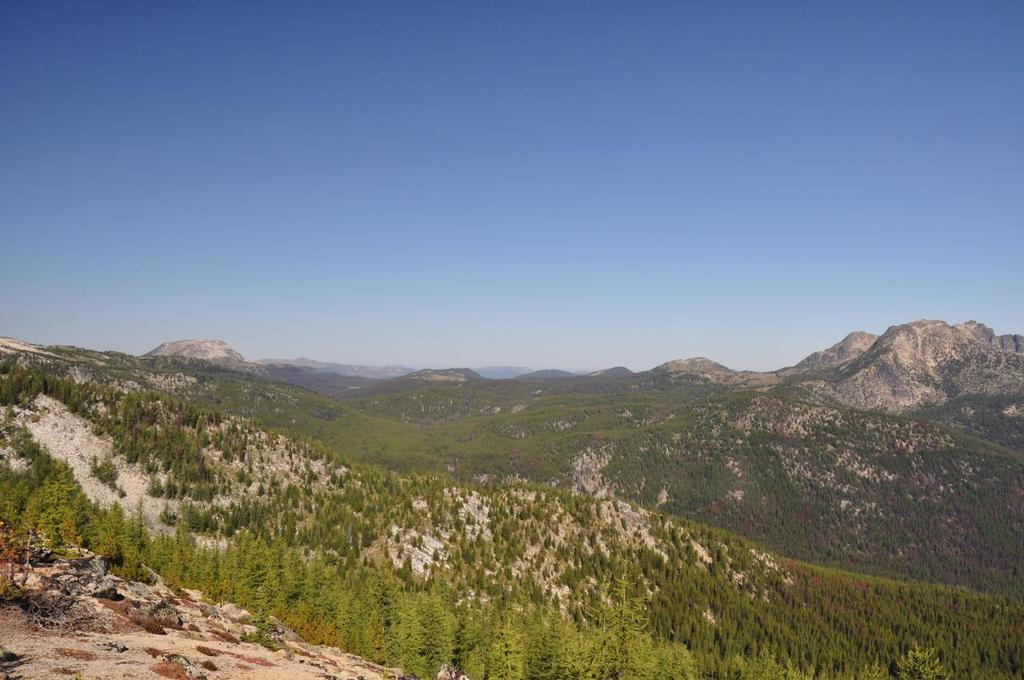What type of terrain is visible in the image? There is ground visible in the image. What natural elements can be seen in the image? There are trees and hills visible in the image. What is visible in the background of the image? The sky is visible in the background of the image. Can you see the band performing in the yard in the image? There is no band or yard present in the image; it features ground, trees, hills, and the sky. 